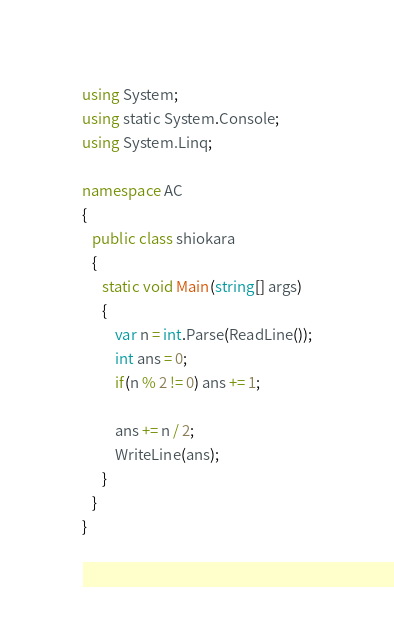<code> <loc_0><loc_0><loc_500><loc_500><_C#_>using System;
using static System.Console;
using System.Linq;

namespace AC
{
   public class shiokara
   {
      static void Main(string[] args)
      {
          var n = int.Parse(ReadLine());
          int ans = 0;
          if(n % 2 != 0) ans += 1;

          ans += n / 2;
          WriteLine(ans);
      }
   }
}</code> 